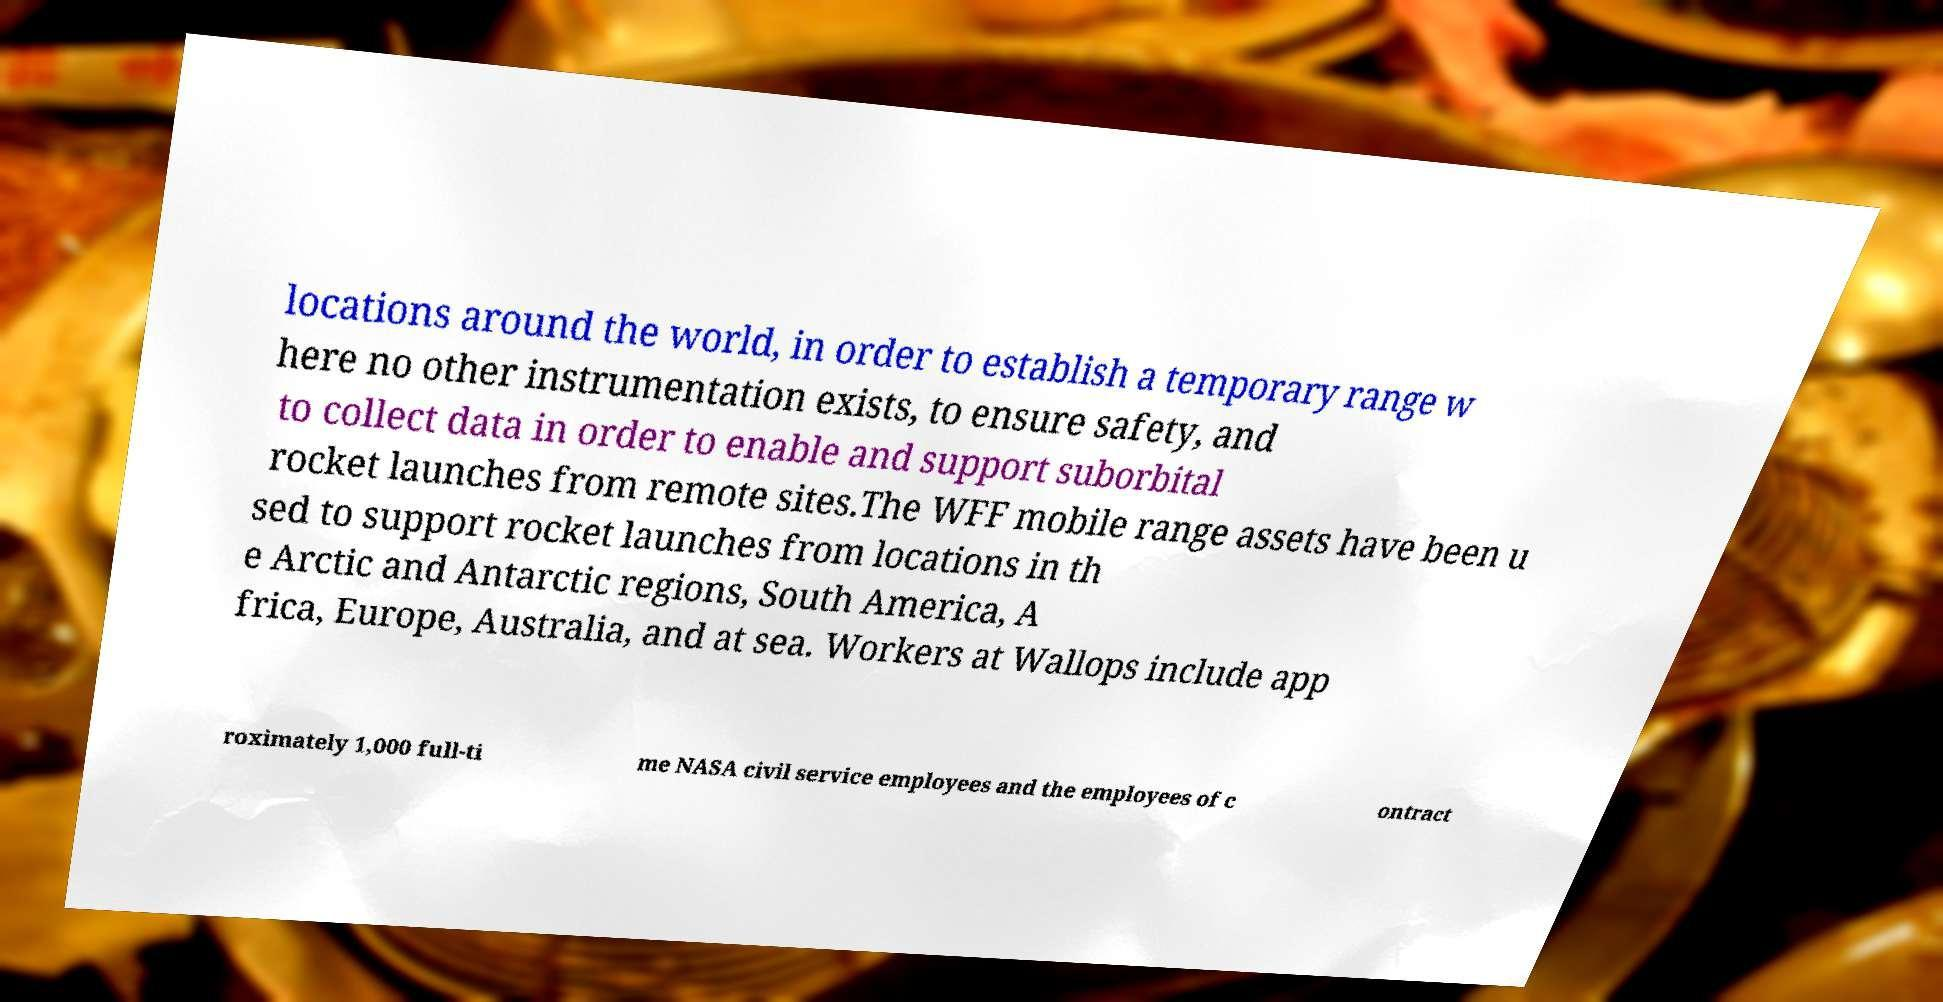Could you assist in decoding the text presented in this image and type it out clearly? locations around the world, in order to establish a temporary range w here no other instrumentation exists, to ensure safety, and to collect data in order to enable and support suborbital rocket launches from remote sites.The WFF mobile range assets have been u sed to support rocket launches from locations in th e Arctic and Antarctic regions, South America, A frica, Europe, Australia, and at sea. Workers at Wallops include app roximately 1,000 full-ti me NASA civil service employees and the employees of c ontract 